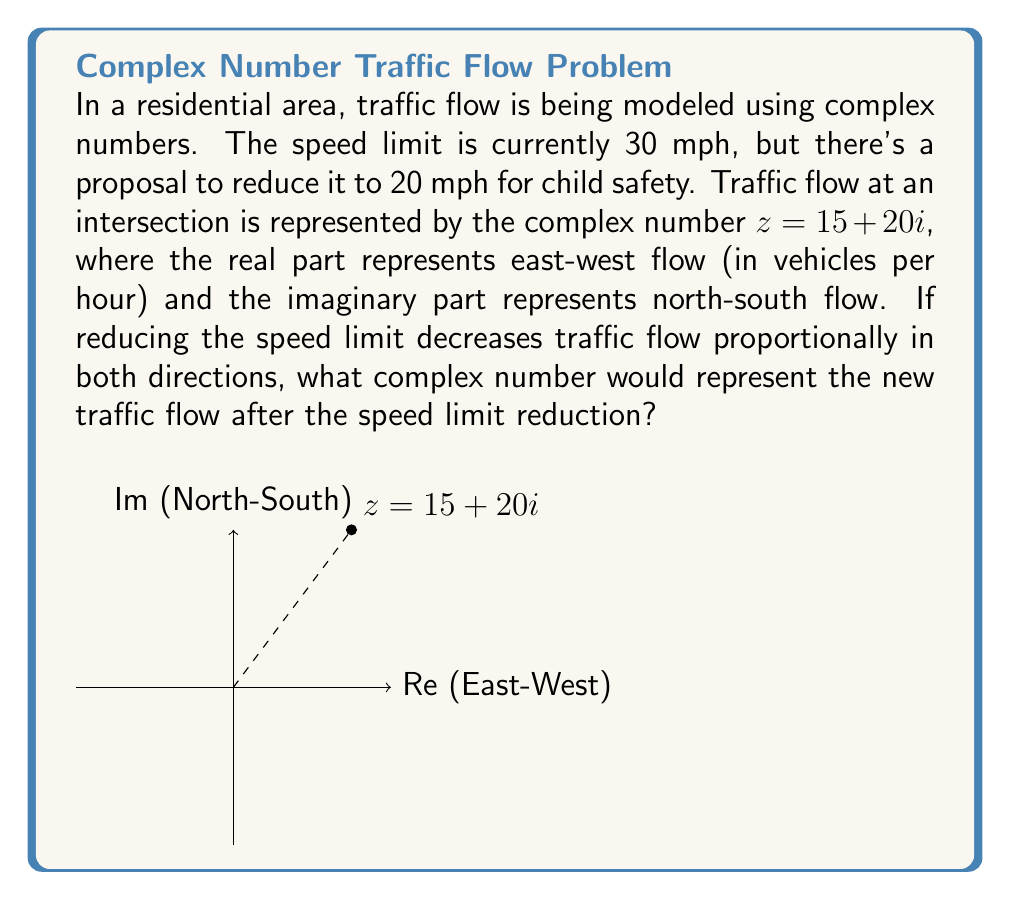Teach me how to tackle this problem. Let's approach this step-by-step:

1) The current traffic flow is represented by $z = 15 + 20i$.

2) The speed limit reduction is from 30 mph to 20 mph. To find the proportion of the reduction:

   $\frac{20}{30} = \frac{2}{3}$

3) This means the new traffic flow will be $\frac{2}{3}$ of the original flow in both directions.

4) For the real part (east-west flow):
   $15 \cdot \frac{2}{3} = 10$

5) For the imaginary part (north-south flow):
   $20 \cdot \frac{2}{3} = \frac{40}{3} \approx 13.33$

6) Therefore, the new complex number representing the traffic flow will be:

   $z_{new} = 10 + \frac{40}{3}i$

This complex number represents the reduced traffic flow after implementing the lower speed limit, which is crucial for child safety in residential areas.
Answer: $10 + \frac{40}{3}i$ 